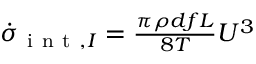<formula> <loc_0><loc_0><loc_500><loc_500>\begin{array} { r } { \dot { \sigma } _ { i n t , I } = \frac { \pi \rho d f L } { 8 T } { U ^ { 3 } } } \end{array}</formula> 